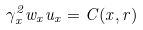<formula> <loc_0><loc_0><loc_500><loc_500>\gamma _ { x } ^ { 2 } w _ { x } u _ { x } = C ( x , r )</formula> 